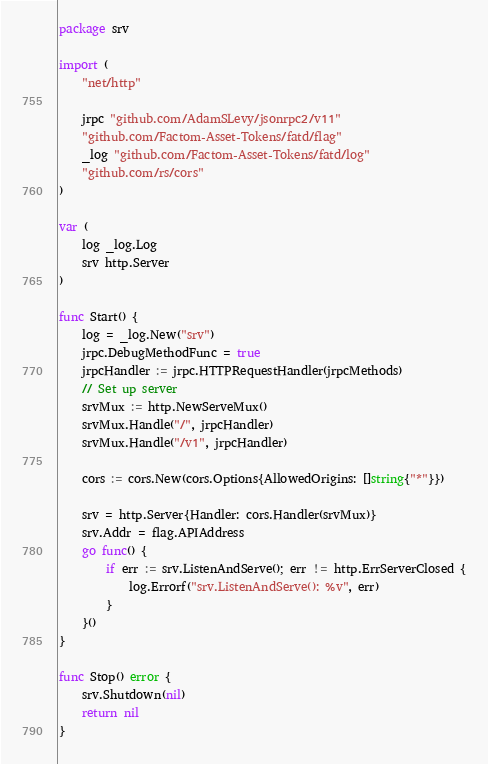Convert code to text. <code><loc_0><loc_0><loc_500><loc_500><_Go_>package srv

import (
	"net/http"

	jrpc "github.com/AdamSLevy/jsonrpc2/v11"
	"github.com/Factom-Asset-Tokens/fatd/flag"
	_log "github.com/Factom-Asset-Tokens/fatd/log"
	"github.com/rs/cors"
)

var (
	log _log.Log
	srv http.Server
)

func Start() {
	log = _log.New("srv")
	jrpc.DebugMethodFunc = true
	jrpcHandler := jrpc.HTTPRequestHandler(jrpcMethods)
	// Set up server
	srvMux := http.NewServeMux()
	srvMux.Handle("/", jrpcHandler)
	srvMux.Handle("/v1", jrpcHandler)

	cors := cors.New(cors.Options{AllowedOrigins: []string{"*"}})

	srv = http.Server{Handler: cors.Handler(srvMux)}
	srv.Addr = flag.APIAddress
	go func() {
		if err := srv.ListenAndServe(); err != http.ErrServerClosed {
			log.Errorf("srv.ListenAndServe(): %v", err)
		}
	}()
}

func Stop() error {
	srv.Shutdown(nil)
	return nil
}
</code> 